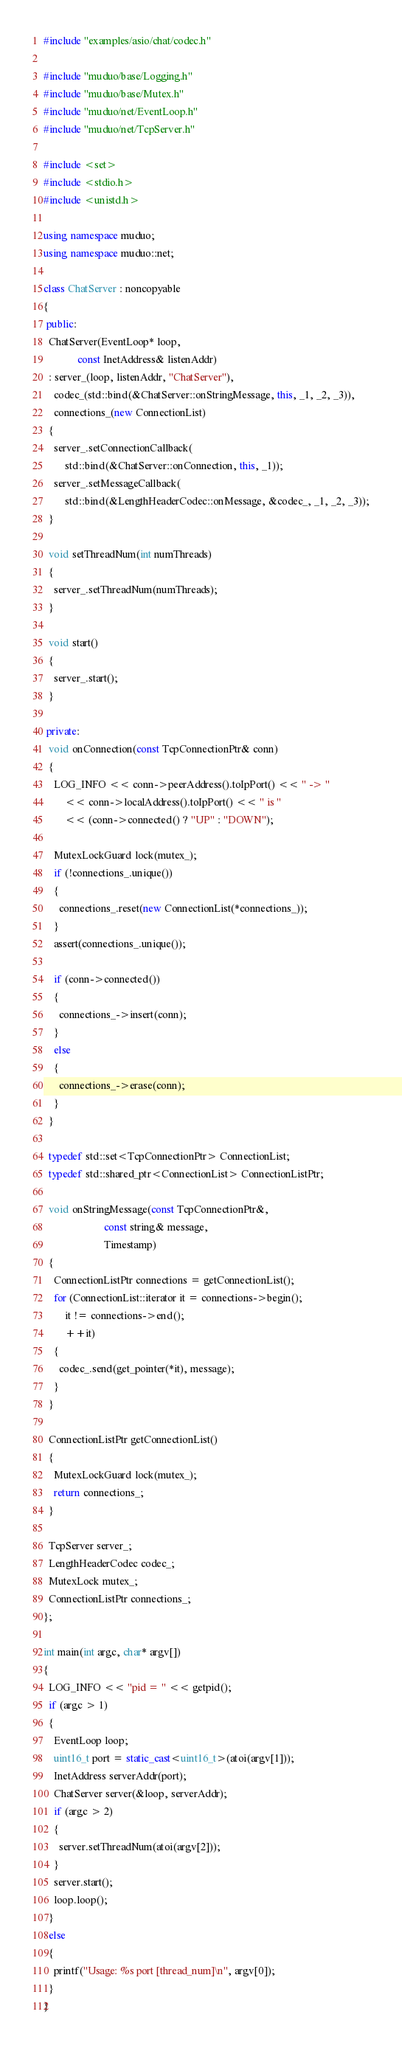Convert code to text. <code><loc_0><loc_0><loc_500><loc_500><_C++_>#include "examples/asio/chat/codec.h"

#include "muduo/base/Logging.h"
#include "muduo/base/Mutex.h"
#include "muduo/net/EventLoop.h"
#include "muduo/net/TcpServer.h"

#include <set>
#include <stdio.h>
#include <unistd.h>

using namespace muduo;
using namespace muduo::net;

class ChatServer : noncopyable
{
 public:
  ChatServer(EventLoop* loop,
             const InetAddress& listenAddr)
  : server_(loop, listenAddr, "ChatServer"),
    codec_(std::bind(&ChatServer::onStringMessage, this, _1, _2, _3)),
    connections_(new ConnectionList)
  {
    server_.setConnectionCallback(
        std::bind(&ChatServer::onConnection, this, _1));
    server_.setMessageCallback(
        std::bind(&LengthHeaderCodec::onMessage, &codec_, _1, _2, _3));
  }

  void setThreadNum(int numThreads)
  {
    server_.setThreadNum(numThreads);
  }

  void start()
  {
    server_.start();
  }

 private:
  void onConnection(const TcpConnectionPtr& conn)
  {
    LOG_INFO << conn->peerAddress().toIpPort() << " -> "
        << conn->localAddress().toIpPort() << " is "
        << (conn->connected() ? "UP" : "DOWN");

    MutexLockGuard lock(mutex_);
    if (!connections_.unique())
    {
      connections_.reset(new ConnectionList(*connections_));
    }
    assert(connections_.unique());

    if (conn->connected())
    {
      connections_->insert(conn);
    }
    else
    {
      connections_->erase(conn);
    }
  }

  typedef std::set<TcpConnectionPtr> ConnectionList;
  typedef std::shared_ptr<ConnectionList> ConnectionListPtr;

  void onStringMessage(const TcpConnectionPtr&,
                       const string& message,
                       Timestamp)
  {
    ConnectionListPtr connections = getConnectionList();
    for (ConnectionList::iterator it = connections->begin();
        it != connections->end();
        ++it)
    {
      codec_.send(get_pointer(*it), message);
    }
  }

  ConnectionListPtr getConnectionList()
  {
    MutexLockGuard lock(mutex_);
    return connections_;
  }

  TcpServer server_;
  LengthHeaderCodec codec_;
  MutexLock mutex_;
  ConnectionListPtr connections_;
};

int main(int argc, char* argv[])
{
  LOG_INFO << "pid = " << getpid();
  if (argc > 1)
  {
    EventLoop loop;
    uint16_t port = static_cast<uint16_t>(atoi(argv[1]));
    InetAddress serverAddr(port);
    ChatServer server(&loop, serverAddr);
    if (argc > 2)
    {
      server.setThreadNum(atoi(argv[2]));
    }
    server.start();
    loop.loop();
  }
  else
  {
    printf("Usage: %s port [thread_num]\n", argv[0]);
  }
}

</code> 